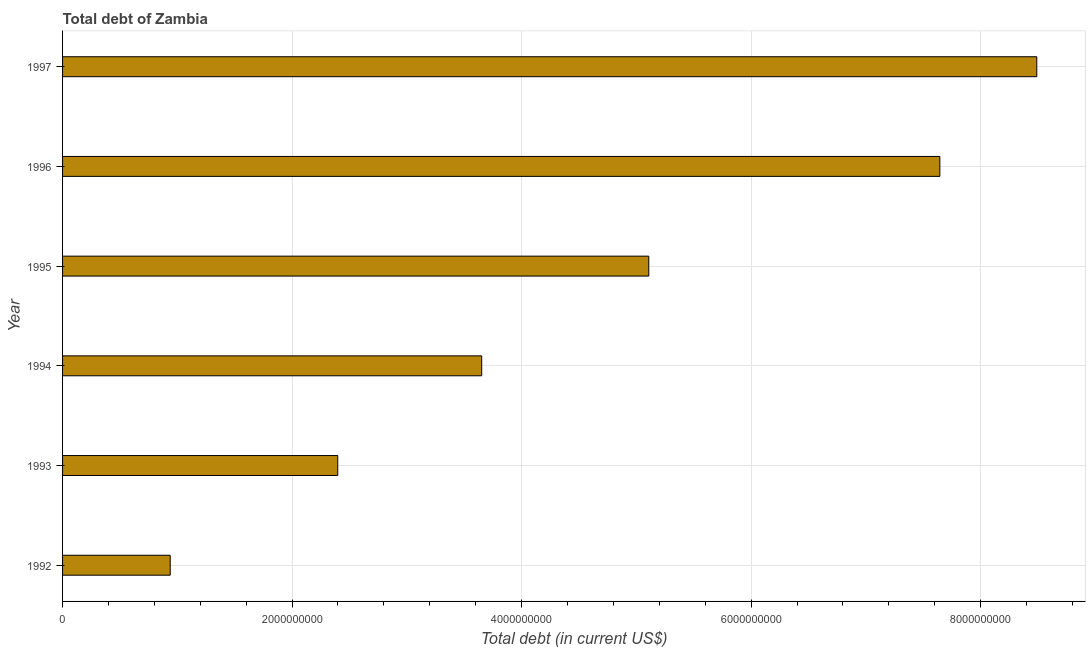Does the graph contain any zero values?
Make the answer very short. No. What is the title of the graph?
Ensure brevity in your answer.  Total debt of Zambia. What is the label or title of the X-axis?
Your response must be concise. Total debt (in current US$). What is the label or title of the Y-axis?
Your answer should be very brief. Year. What is the total debt in 1994?
Provide a succinct answer. 3.65e+09. Across all years, what is the maximum total debt?
Provide a succinct answer. 8.49e+09. Across all years, what is the minimum total debt?
Offer a terse response. 9.38e+08. In which year was the total debt maximum?
Your answer should be compact. 1997. In which year was the total debt minimum?
Keep it short and to the point. 1992. What is the sum of the total debt?
Provide a succinct answer. 2.82e+1. What is the difference between the total debt in 1995 and 1997?
Your answer should be very brief. -3.38e+09. What is the average total debt per year?
Give a very brief answer. 4.71e+09. What is the median total debt?
Give a very brief answer. 4.38e+09. What is the ratio of the total debt in 1996 to that in 1997?
Offer a terse response. 0.9. Is the total debt in 1994 less than that in 1995?
Keep it short and to the point. Yes. Is the difference between the total debt in 1992 and 1997 greater than the difference between any two years?
Provide a short and direct response. Yes. What is the difference between the highest and the second highest total debt?
Make the answer very short. 8.45e+08. What is the difference between the highest and the lowest total debt?
Your answer should be very brief. 7.55e+09. In how many years, is the total debt greater than the average total debt taken over all years?
Provide a succinct answer. 3. How many bars are there?
Offer a very short reply. 6. Are all the bars in the graph horizontal?
Give a very brief answer. Yes. Are the values on the major ticks of X-axis written in scientific E-notation?
Make the answer very short. No. What is the Total debt (in current US$) of 1992?
Keep it short and to the point. 9.38e+08. What is the Total debt (in current US$) of 1993?
Your response must be concise. 2.40e+09. What is the Total debt (in current US$) of 1994?
Ensure brevity in your answer.  3.65e+09. What is the Total debt (in current US$) of 1995?
Your response must be concise. 5.11e+09. What is the Total debt (in current US$) of 1996?
Offer a terse response. 7.64e+09. What is the Total debt (in current US$) in 1997?
Provide a short and direct response. 8.49e+09. What is the difference between the Total debt (in current US$) in 1992 and 1993?
Give a very brief answer. -1.46e+09. What is the difference between the Total debt (in current US$) in 1992 and 1994?
Give a very brief answer. -2.71e+09. What is the difference between the Total debt (in current US$) in 1992 and 1995?
Your answer should be very brief. -4.17e+09. What is the difference between the Total debt (in current US$) in 1992 and 1996?
Keep it short and to the point. -6.71e+09. What is the difference between the Total debt (in current US$) in 1992 and 1997?
Provide a short and direct response. -7.55e+09. What is the difference between the Total debt (in current US$) in 1993 and 1994?
Ensure brevity in your answer.  -1.25e+09. What is the difference between the Total debt (in current US$) in 1993 and 1995?
Make the answer very short. -2.71e+09. What is the difference between the Total debt (in current US$) in 1993 and 1996?
Keep it short and to the point. -5.25e+09. What is the difference between the Total debt (in current US$) in 1993 and 1997?
Your answer should be compact. -6.09e+09. What is the difference between the Total debt (in current US$) in 1994 and 1995?
Keep it short and to the point. -1.46e+09. What is the difference between the Total debt (in current US$) in 1994 and 1996?
Offer a very short reply. -3.99e+09. What is the difference between the Total debt (in current US$) in 1994 and 1997?
Make the answer very short. -4.84e+09. What is the difference between the Total debt (in current US$) in 1995 and 1996?
Offer a very short reply. -2.54e+09. What is the difference between the Total debt (in current US$) in 1995 and 1997?
Give a very brief answer. -3.38e+09. What is the difference between the Total debt (in current US$) in 1996 and 1997?
Your response must be concise. -8.45e+08. What is the ratio of the Total debt (in current US$) in 1992 to that in 1993?
Your answer should be compact. 0.39. What is the ratio of the Total debt (in current US$) in 1992 to that in 1994?
Provide a short and direct response. 0.26. What is the ratio of the Total debt (in current US$) in 1992 to that in 1995?
Make the answer very short. 0.18. What is the ratio of the Total debt (in current US$) in 1992 to that in 1996?
Provide a succinct answer. 0.12. What is the ratio of the Total debt (in current US$) in 1992 to that in 1997?
Keep it short and to the point. 0.11. What is the ratio of the Total debt (in current US$) in 1993 to that in 1994?
Your answer should be very brief. 0.66. What is the ratio of the Total debt (in current US$) in 1993 to that in 1995?
Provide a succinct answer. 0.47. What is the ratio of the Total debt (in current US$) in 1993 to that in 1996?
Ensure brevity in your answer.  0.31. What is the ratio of the Total debt (in current US$) in 1993 to that in 1997?
Your answer should be compact. 0.28. What is the ratio of the Total debt (in current US$) in 1994 to that in 1995?
Offer a very short reply. 0.71. What is the ratio of the Total debt (in current US$) in 1994 to that in 1996?
Give a very brief answer. 0.48. What is the ratio of the Total debt (in current US$) in 1994 to that in 1997?
Give a very brief answer. 0.43. What is the ratio of the Total debt (in current US$) in 1995 to that in 1996?
Give a very brief answer. 0.67. What is the ratio of the Total debt (in current US$) in 1995 to that in 1997?
Ensure brevity in your answer.  0.6. What is the ratio of the Total debt (in current US$) in 1996 to that in 1997?
Your answer should be compact. 0.9. 